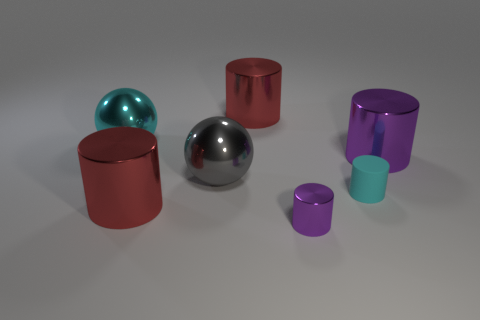Is the shape of the rubber object the same as the gray object?
Ensure brevity in your answer.  No. How many things are either large metallic spheres to the right of the cyan metal thing or red metal cylinders?
Offer a very short reply. 3. There is a cyan sphere that is the same material as the gray thing; what is its size?
Provide a succinct answer. Large. What number of other things have the same color as the tiny matte object?
Your response must be concise. 1. What number of tiny objects are either cyan balls or brown matte cylinders?
Ensure brevity in your answer.  0. There is a shiny sphere that is the same color as the tiny rubber cylinder; what size is it?
Ensure brevity in your answer.  Large. Is there a purple cylinder made of the same material as the cyan sphere?
Make the answer very short. Yes. What is the big cylinder on the right side of the tiny metal object made of?
Keep it short and to the point. Metal. Is the color of the tiny rubber thing that is right of the tiny purple object the same as the big shiny ball on the right side of the big cyan shiny sphere?
Your answer should be compact. No. The other ball that is the same size as the gray sphere is what color?
Provide a short and direct response. Cyan. 